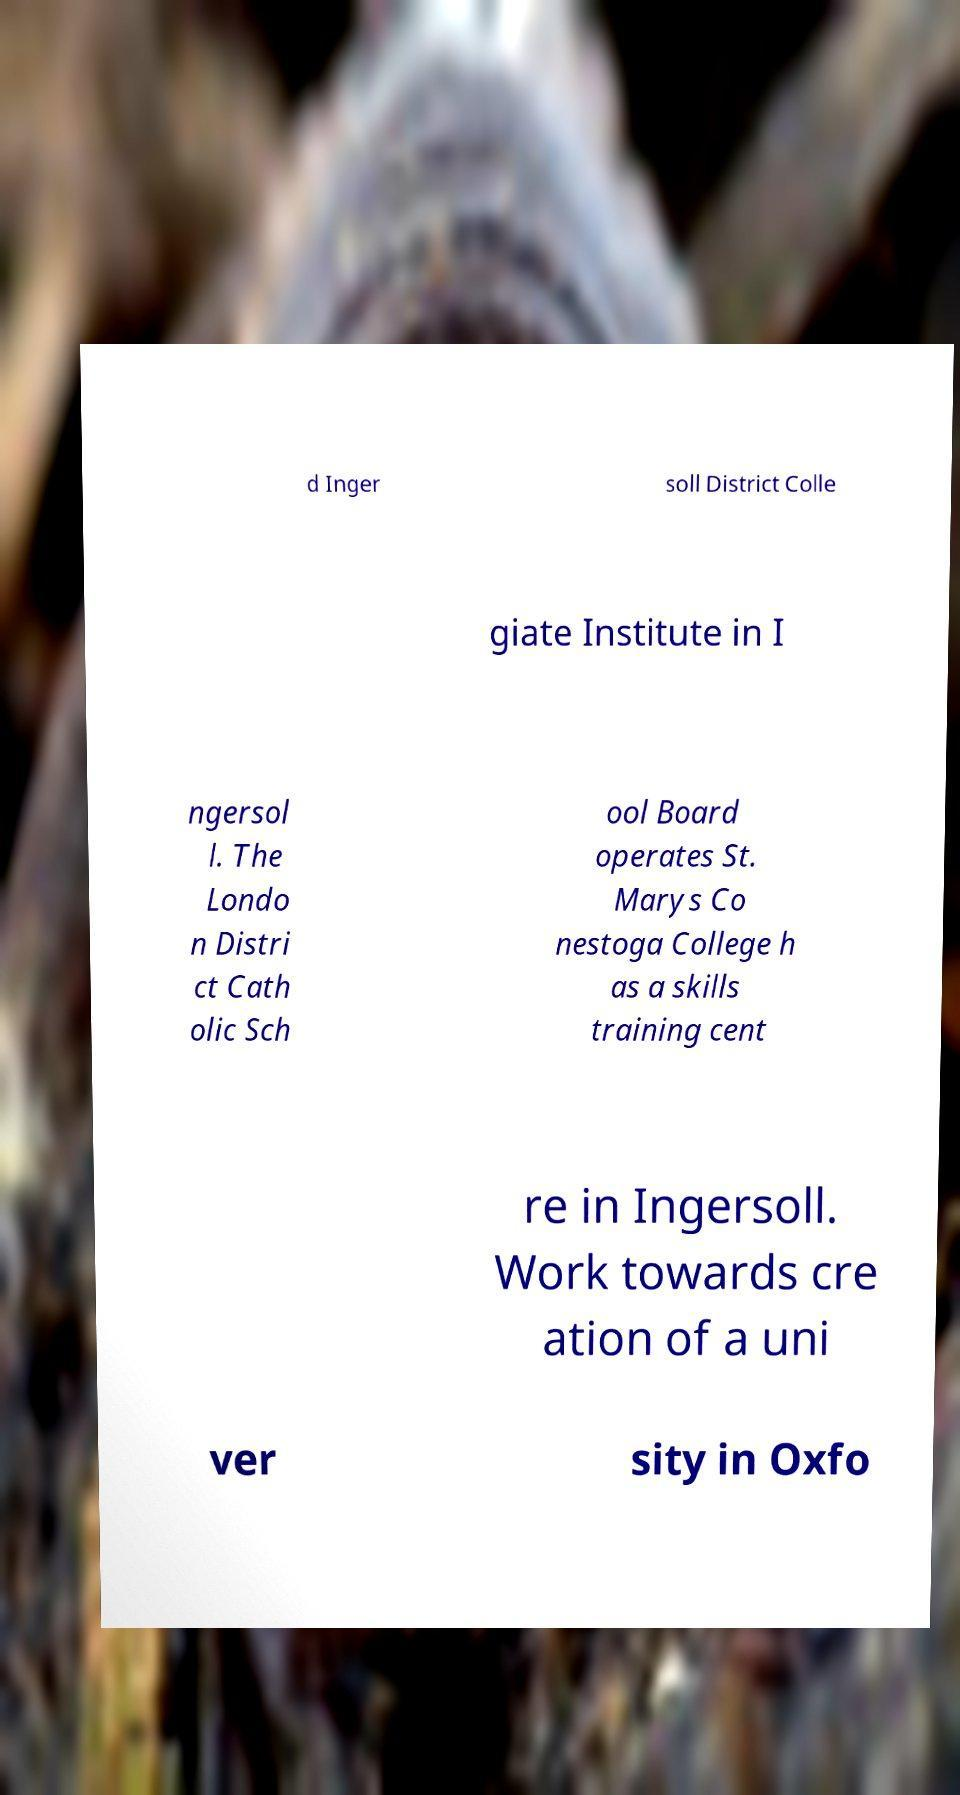There's text embedded in this image that I need extracted. Can you transcribe it verbatim? d Inger soll District Colle giate Institute in I ngersol l. The Londo n Distri ct Cath olic Sch ool Board operates St. Marys Co nestoga College h as a skills training cent re in Ingersoll. Work towards cre ation of a uni ver sity in Oxfo 